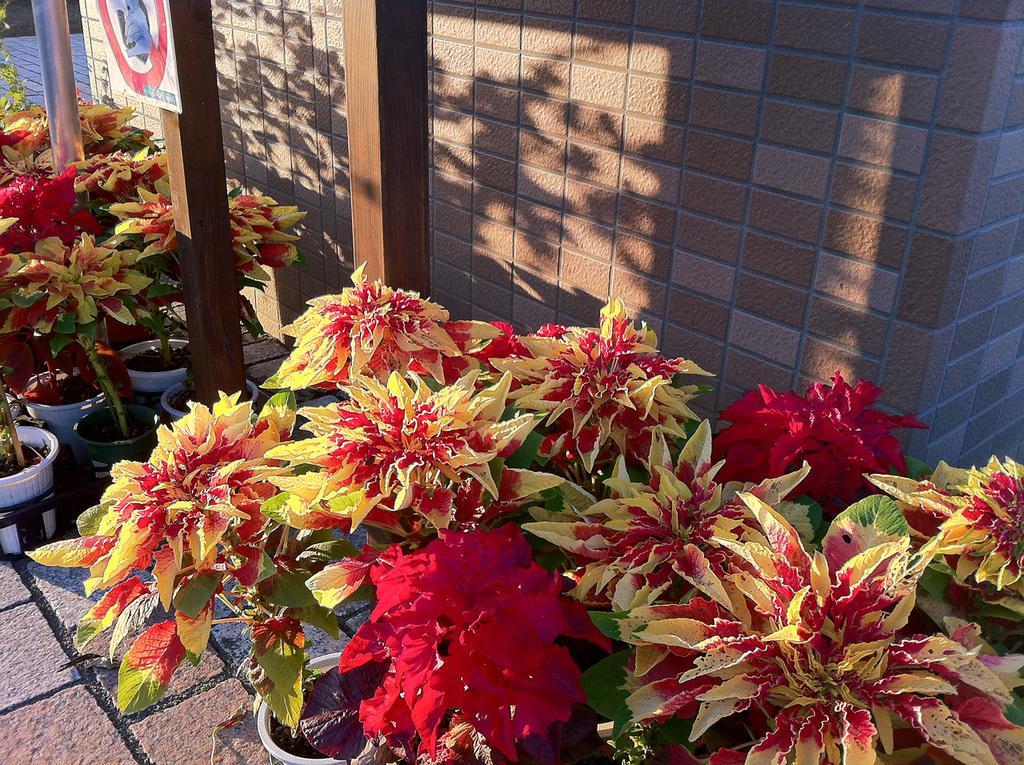Please provide a concise description of this image. In this image we can see house plants. In the background we can see wall and poles. 